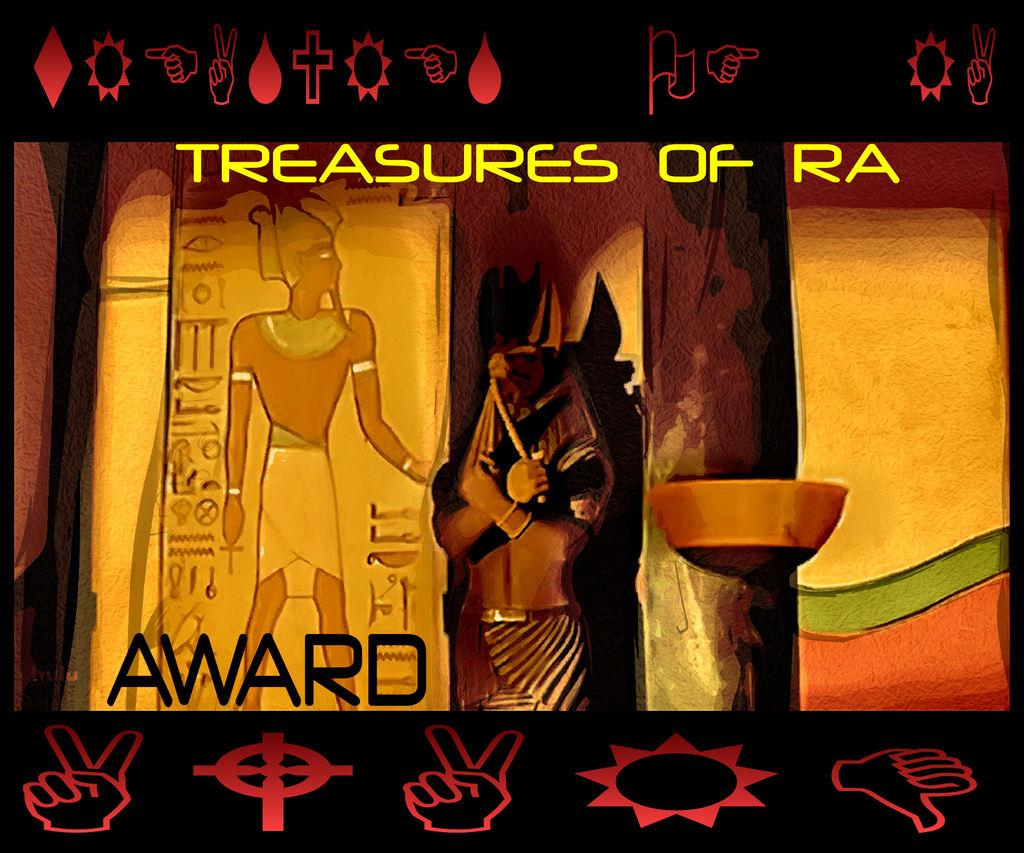What type of image is being described? The image is animated. What can be seen in the image besides the animation? There is a statue in the image. Are there any branding elements in the image? Yes, there are logos in the image. Is there any written information in the image? Yes, there is text written on the image. How many tomatoes are on the dinner table in the image? There is no dinner table or tomatoes present in the image. What type of cub is visible in the image? There is no cub present in the image. 